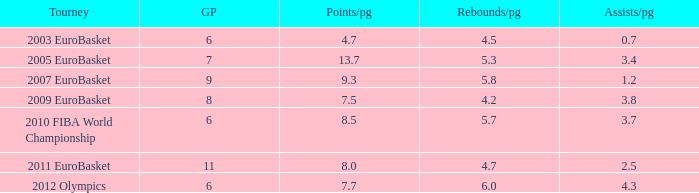Would you mind parsing the complete table? {'header': ['Tourney', 'GP', 'Points/pg', 'Rebounds/pg', 'Assists/pg'], 'rows': [['2003 EuroBasket', '6', '4.7', '4.5', '0.7'], ['2005 EuroBasket', '7', '13.7', '5.3', '3.4'], ['2007 EuroBasket', '9', '9.3', '5.8', '1.2'], ['2009 EuroBasket', '8', '7.5', '4.2', '3.8'], ['2010 FIBA World Championship', '6', '8.5', '5.7', '3.7'], ['2011 EuroBasket', '11', '8.0', '4.7', '2.5'], ['2012 Olympics', '6', '7.7', '6.0', '4.3']]} How may assists per game have 7.7 points per game? 4.3. 